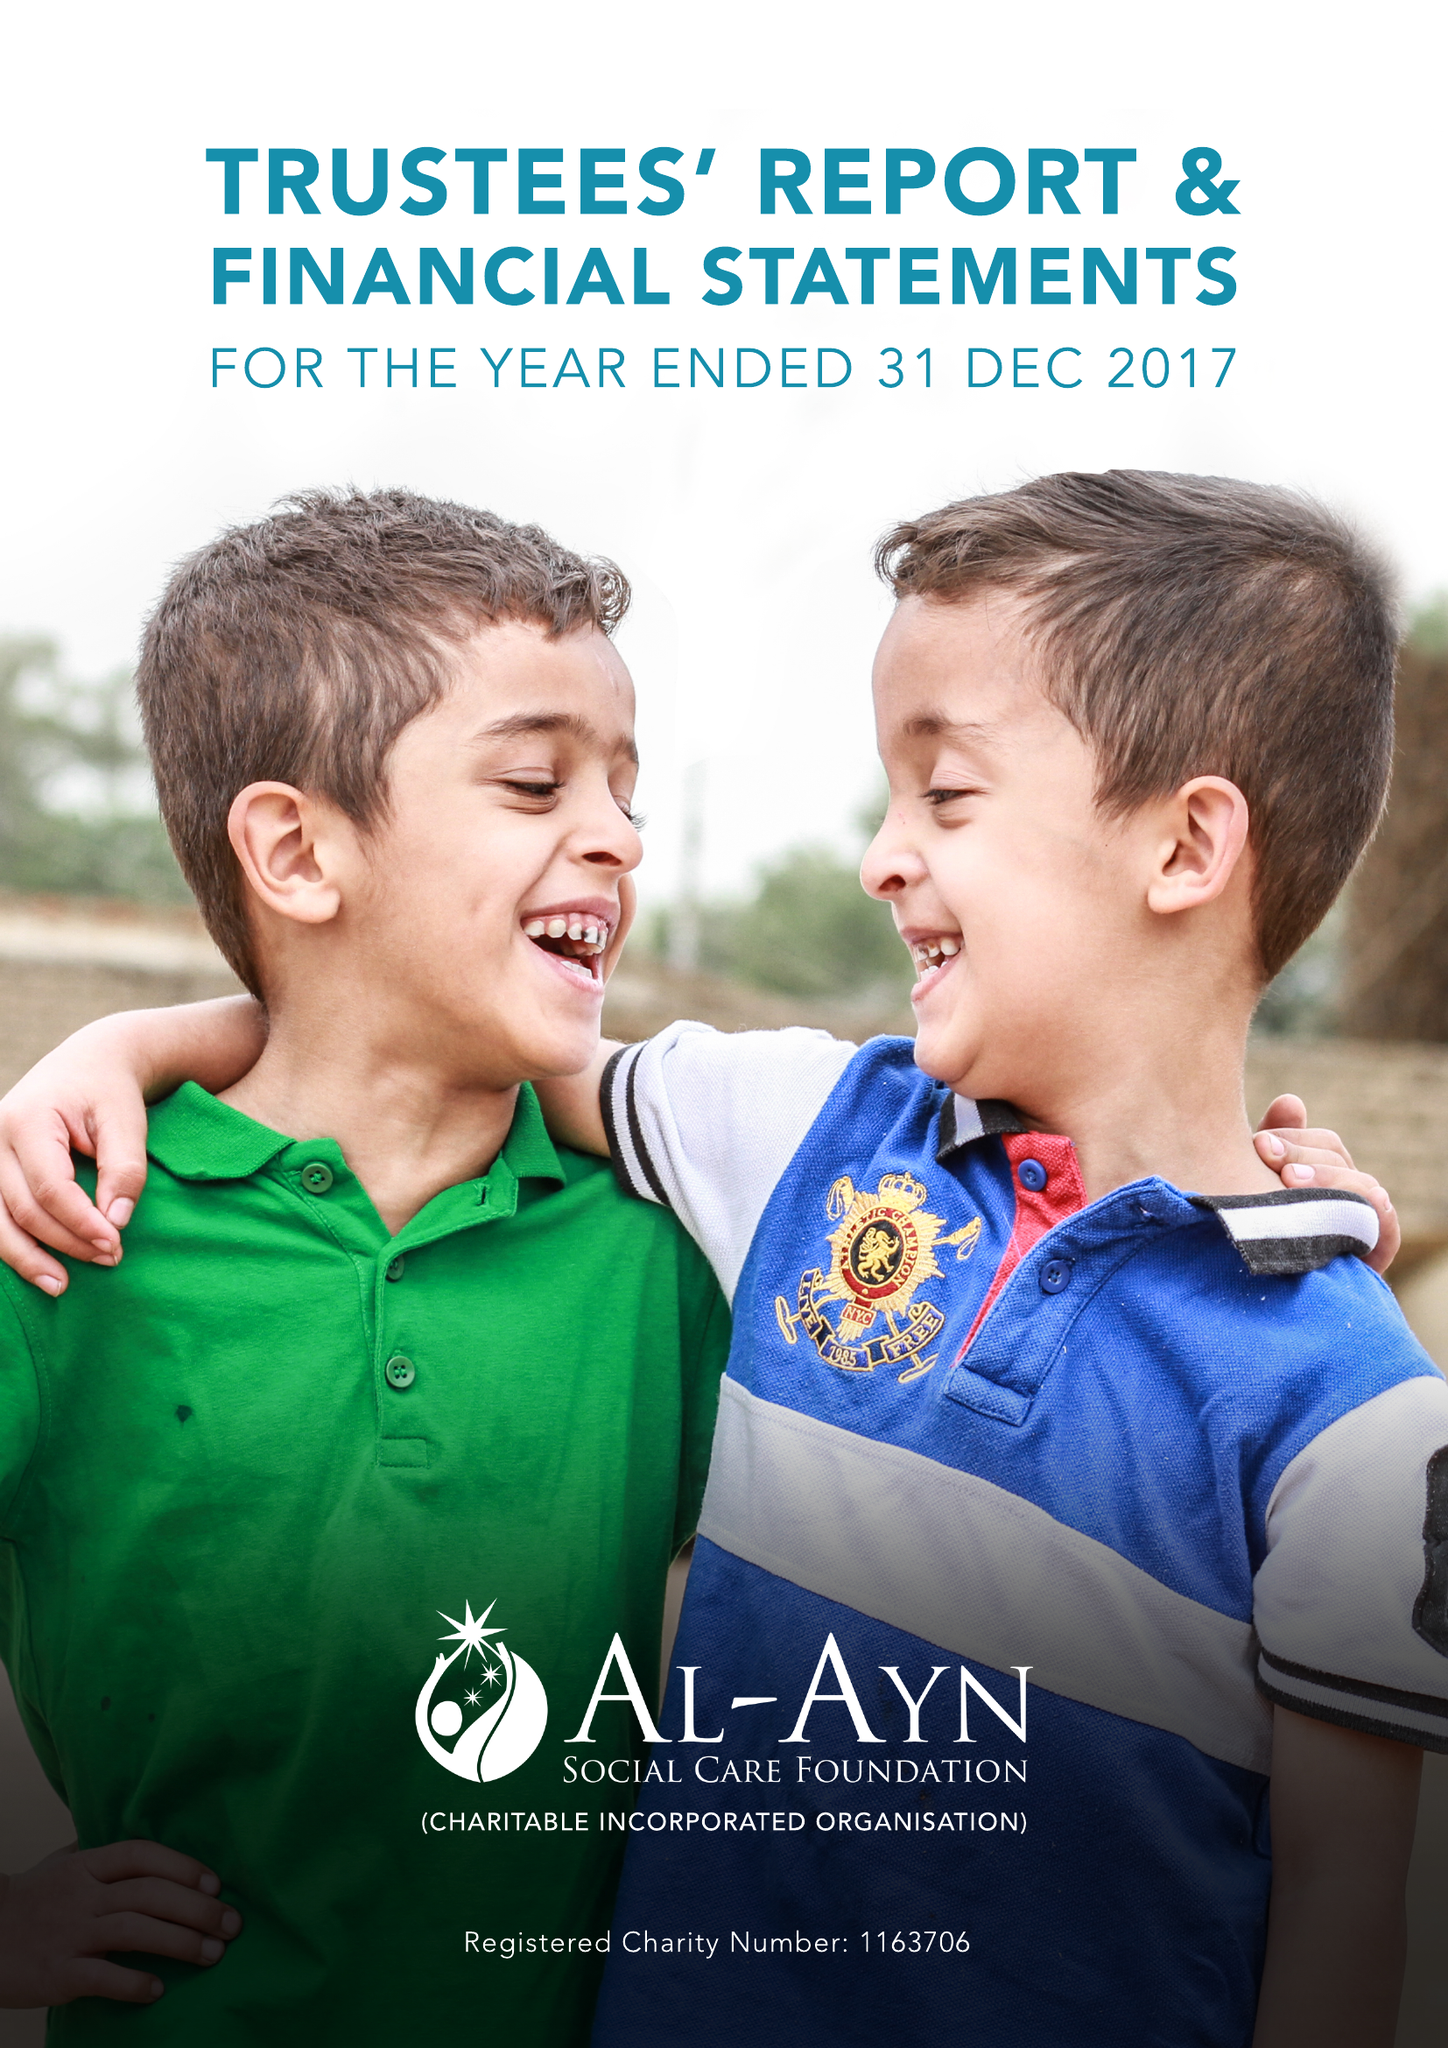What is the value for the spending_annually_in_british_pounds?
Answer the question using a single word or phrase. 13795279.00 